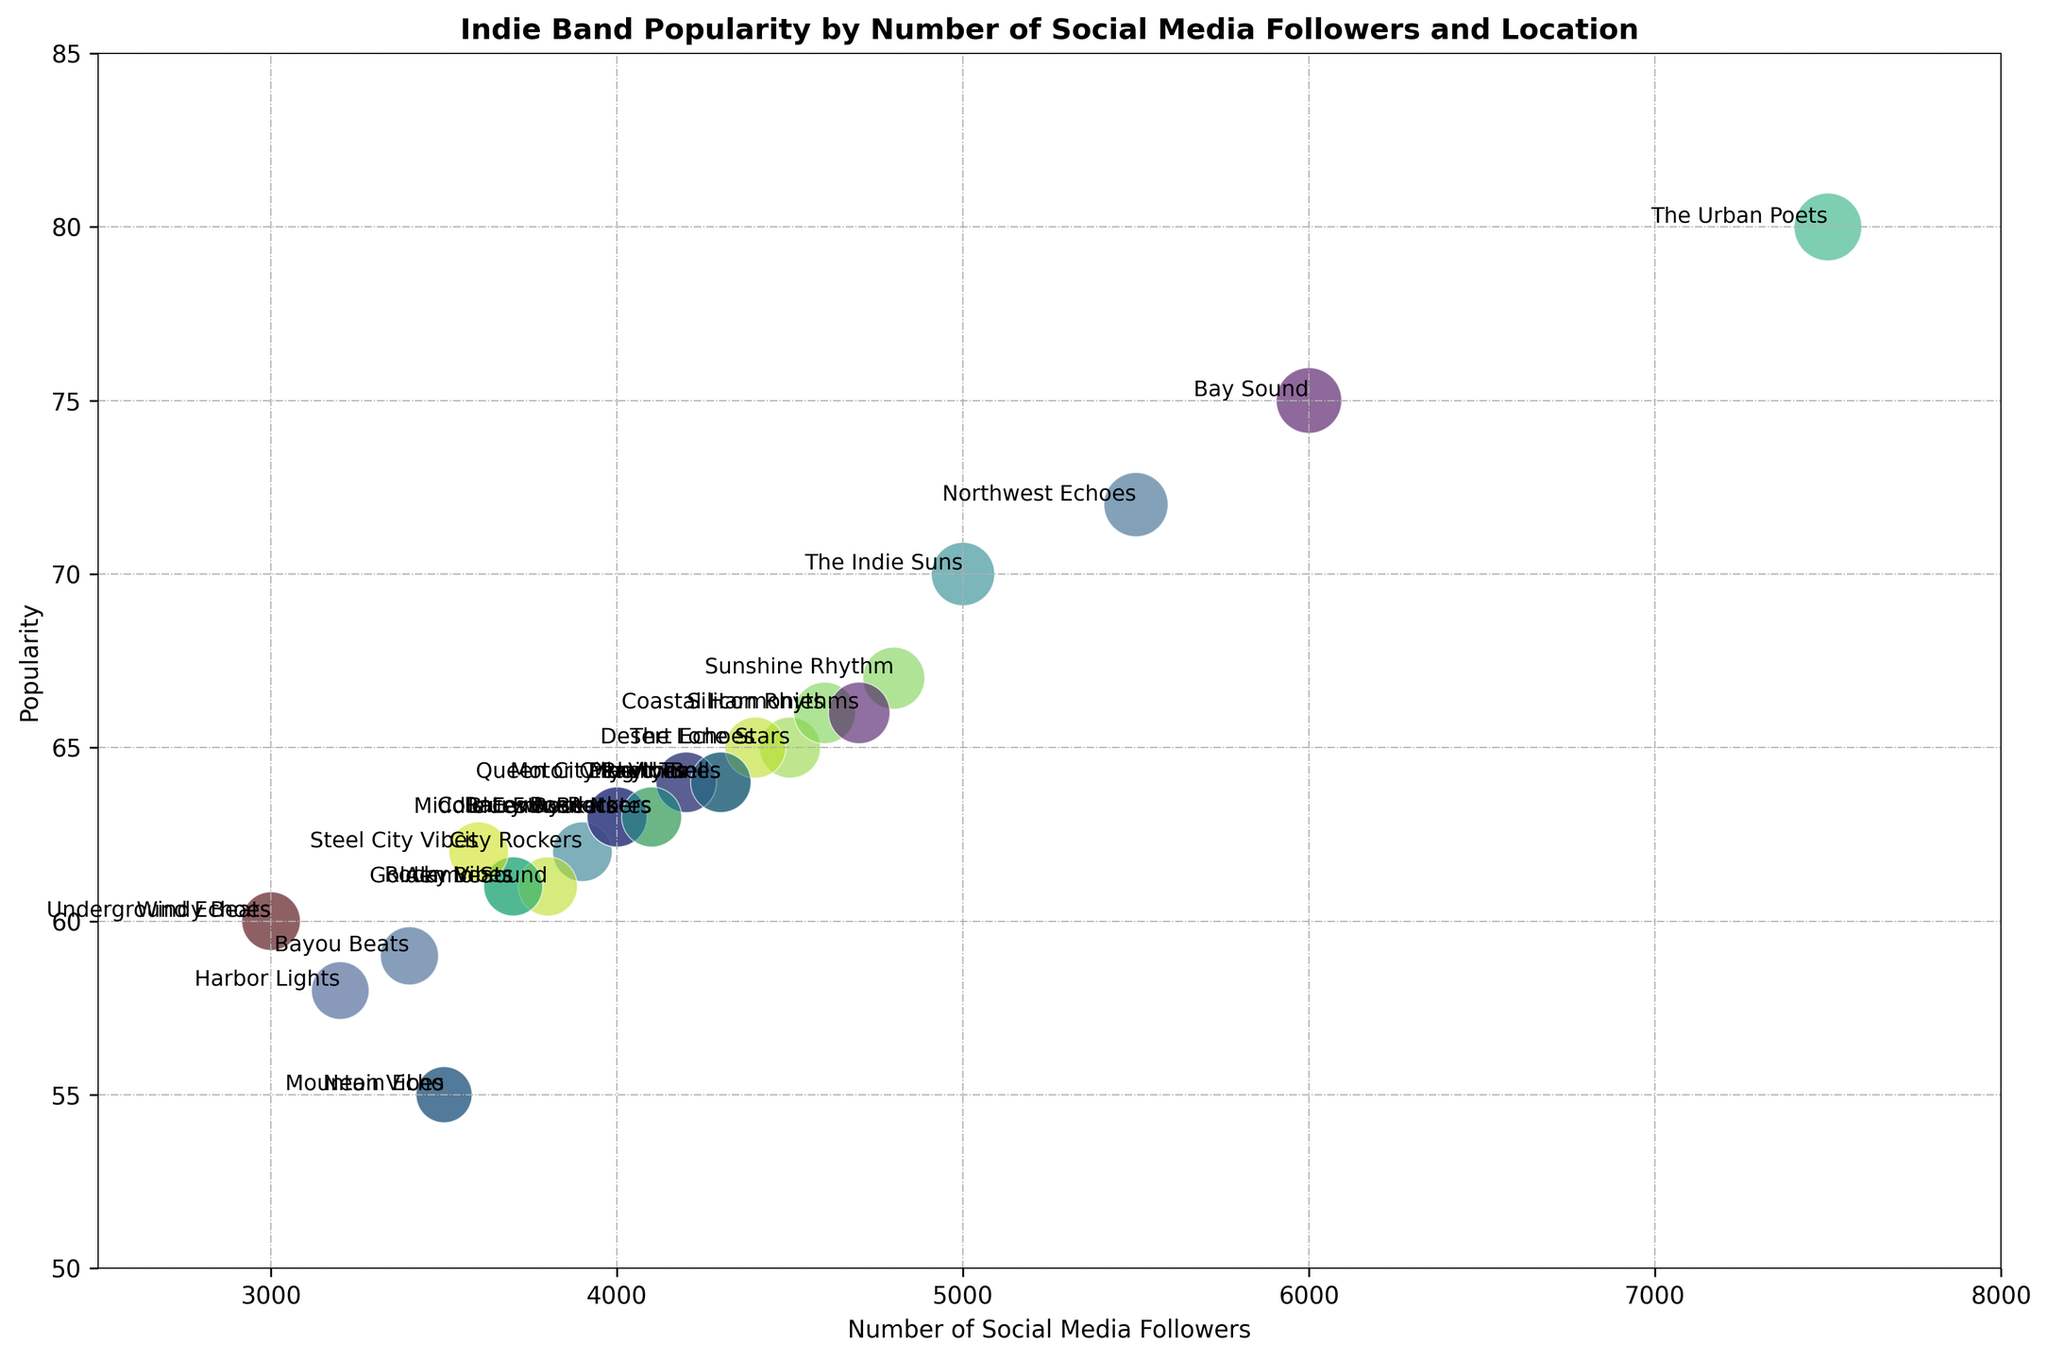Which band has the highest popularity? By looking at the vertical position (y-axis) of the bubbles, the highest bubble represents the highest popularity value. The Urban Poets are at the top.
Answer: The Urban Poets Which band has the lowest number of social media followers? By looking at the horizontal position (x-axis) of the bubbles, the leftmost bubble represents the lowest number of social media followers. Windy Beats has the lowest with 3000 followers.
Answer: Windy Beats Which band has a higher follower count, Mountain Echo or Bay Sound? By comparing the horizontal positions of the bubbles for Mountain Echo and Bay Sound, Bay Sound is further to the right, representing a higher follower count.
Answer: Bay Sound What is the average popularity of bands with more than 4000 followers? Bands with more than 4000 followers are: The Indie Suns, The Urban Poets, The Lone Stars, Northwest Echoes, Bay Sound, Peach Tunes, Sunshine Rhythm, Coastal Harmonies, Desert Echoes, Silicon Rhythms. Their popularities are: 70, 80, 65, 72, 75, 64, 67, 66, 65, 66. Sum = 730, count = 10. Average = 730/10 = 73.
Answer: 73 Between Liberty Bells and Magic Tunes, which band has a higher popularity? By comparing the vertical positions of the bubbles for Liberty Bells and Magic Tunes, Magic Tunes is slightly higher, indicating a higher popularity.
Answer: Magic Tunes Which geographical location has the largest bubble? By comparing the sizes of the bubbles, The Urban Poets from New York have the largest bubble.
Answer: New York What is the difference in the number of followers between The Urban Poets and The Indie Suns? The number of followers for The Urban Poets is 7500, and for The Indie Suns is 5000. Difference = 7500 - 5000 = 2500.
Answer: 2500 Are there any bands with the same number of followers and, if so, which ones? By looking at the horizontal positions on the x-axis, we notice that Peach Tunes and Liberty Bells (both with 4300 followers) and the City Rockers, Frozen Notes, and Middle Earth Beats (all with 4000 followers) have the same number of followers.
Answer: Peach Tunes and Liberty Bells; City Rockers, Frozen Notes, and Middle Earth Beats Which two bands have the lowest popularity and what are their values? The lowest popularity values are represented by the lowest bubbles. Mountain Echo and Neon Vibes both have the lowest popularity at 55.
Answer: Mountain Echo and Neon Vibes, 55 What is the total number of followers for the bands based in Seattle? The bands based in Seattle are Northwest Echoes with 5500 followers and Underground Echoes with 3000 followers. Total = 5500 + 3000 = 8500.
Answer: 8500 